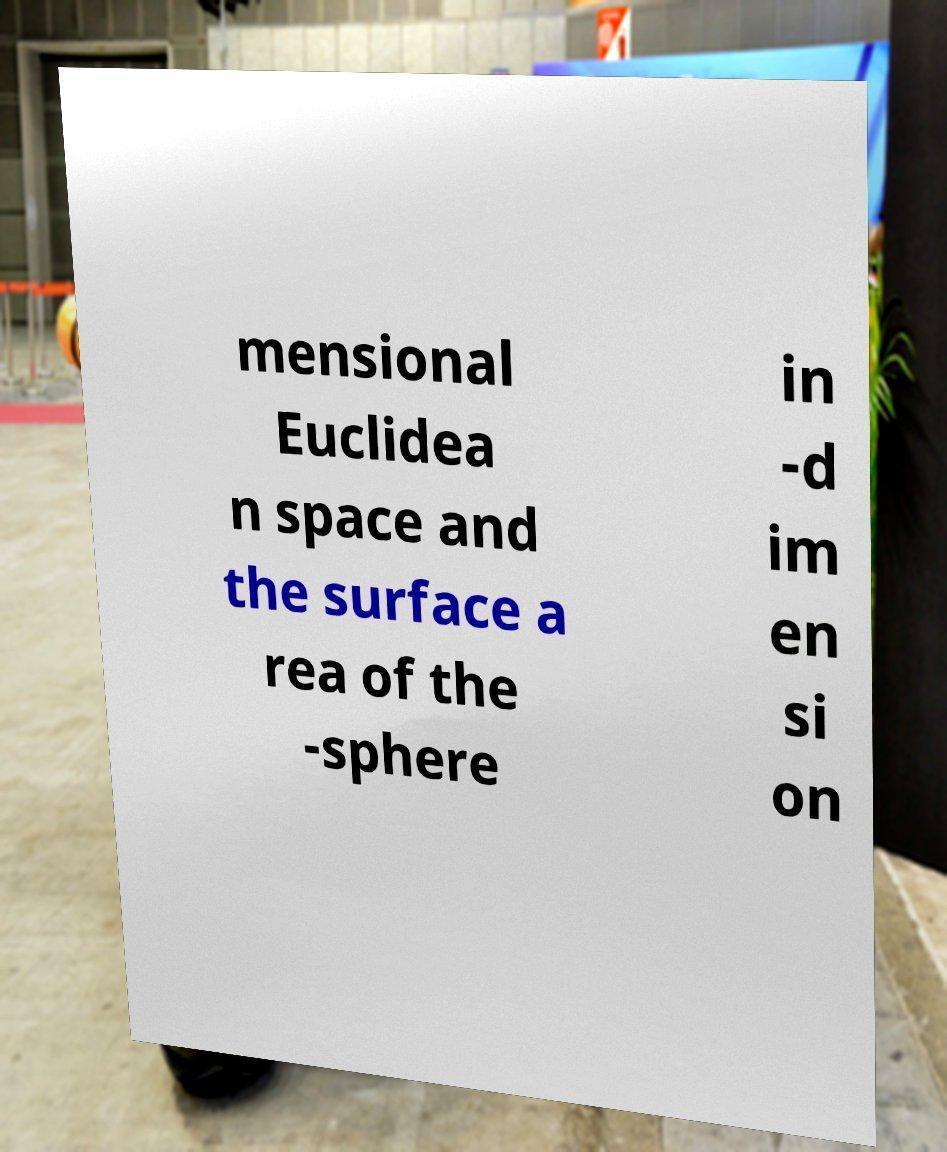I need the written content from this picture converted into text. Can you do that? mensional Euclidea n space and the surface a rea of the -sphere in -d im en si on 